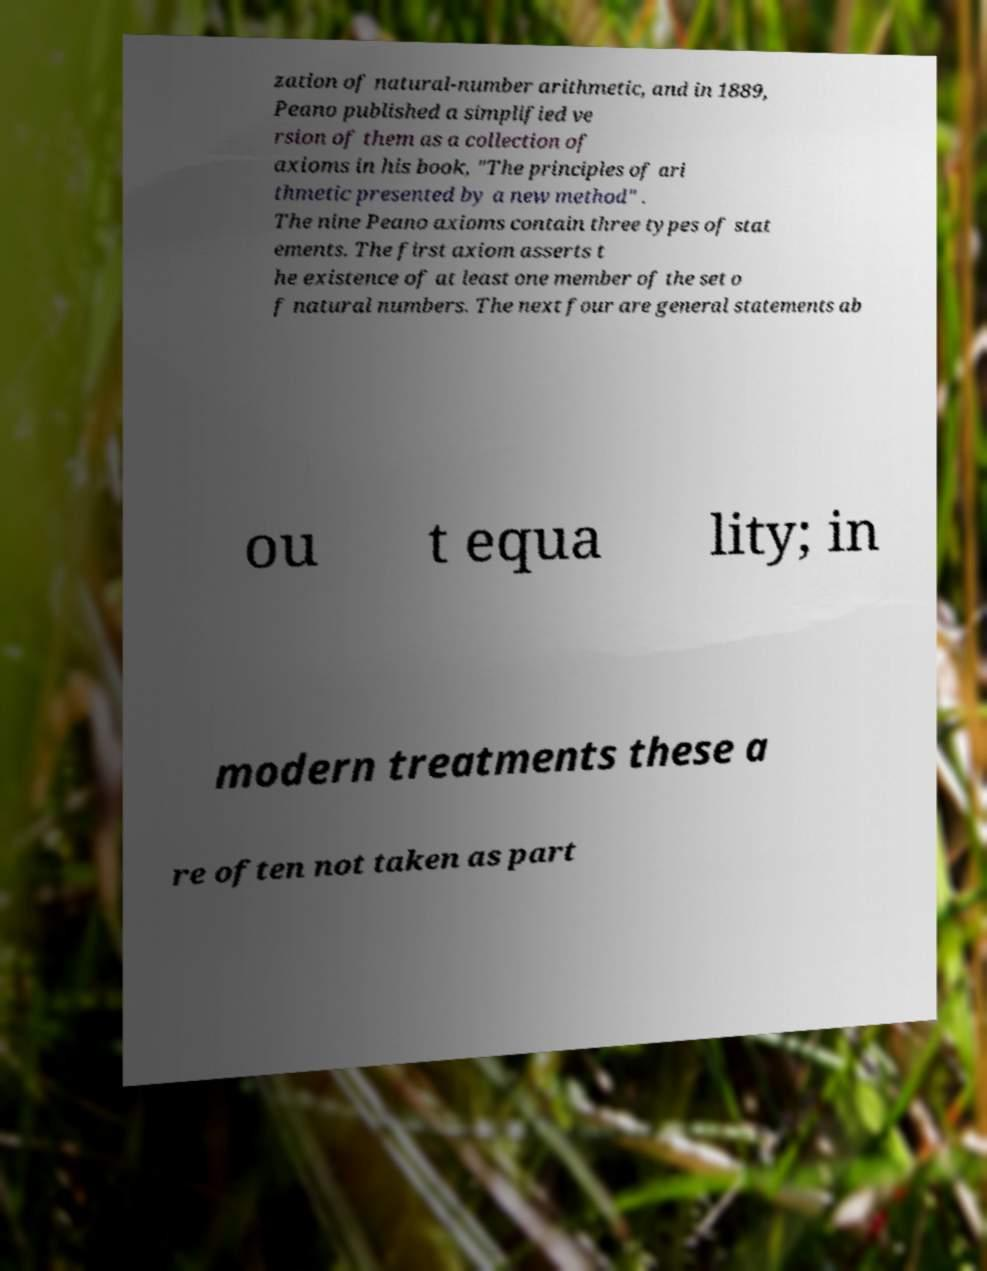For documentation purposes, I need the text within this image transcribed. Could you provide that? zation of natural-number arithmetic, and in 1889, Peano published a simplified ve rsion of them as a collection of axioms in his book, "The principles of ari thmetic presented by a new method" . The nine Peano axioms contain three types of stat ements. The first axiom asserts t he existence of at least one member of the set o f natural numbers. The next four are general statements ab ou t equa lity; in modern treatments these a re often not taken as part 